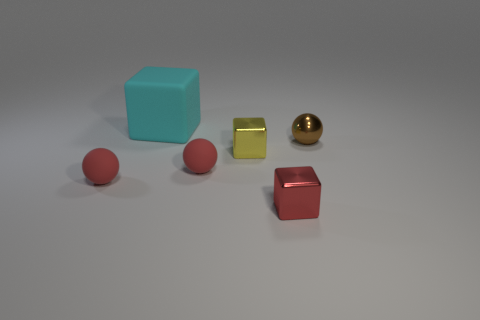What is the shape of the red thing that is both right of the large cyan rubber cube and to the left of the yellow metallic block?
Provide a short and direct response. Sphere. How many other objects are the same material as the small red block?
Offer a terse response. 2. What number of big objects are either gray metal blocks or cyan rubber objects?
Make the answer very short. 1. Is the number of matte balls that are on the left side of the large cyan thing the same as the number of matte cubes?
Your answer should be compact. Yes. There is a small red rubber sphere that is left of the cyan object; is there a metallic ball that is in front of it?
Provide a short and direct response. No. How many other things are there of the same color as the matte cube?
Your answer should be very brief. 0. What color is the big matte thing?
Make the answer very short. Cyan. What is the size of the cube that is both in front of the large cyan object and behind the small red shiny thing?
Provide a succinct answer. Small. What number of objects are either blocks that are on the left side of the small yellow object or red cylinders?
Your response must be concise. 1. What is the shape of the tiny red object that is the same material as the tiny yellow thing?
Keep it short and to the point. Cube. 